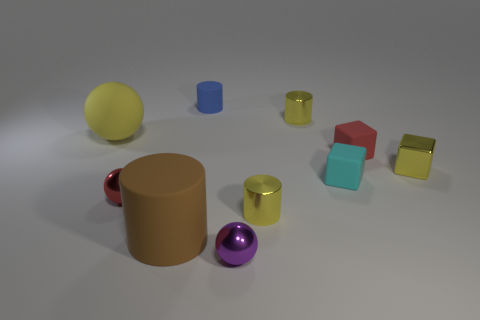Do the tiny rubber cylinder and the metallic cube have the same color?
Keep it short and to the point. No. How many small things are either purple rubber cylinders or cubes?
Ensure brevity in your answer.  3. Is there any other thing that has the same color as the big cylinder?
Offer a terse response. No. What shape is the small blue thing that is made of the same material as the cyan block?
Give a very brief answer. Cylinder. There is a metal ball to the right of the small blue matte cylinder; how big is it?
Offer a terse response. Small. What is the shape of the small cyan rubber object?
Offer a very short reply. Cube. There is a metallic ball on the left side of the purple metal sphere; is it the same size as the red object that is to the right of the purple sphere?
Keep it short and to the point. Yes. There is a red object that is behind the small shiny sphere that is left of the matte cylinder that is behind the large brown rubber thing; how big is it?
Offer a very short reply. Small. The small metallic object that is in front of the tiny yellow thing that is in front of the metallic sphere that is on the left side of the purple shiny thing is what shape?
Give a very brief answer. Sphere. There is a tiny yellow thing behind the big sphere; what shape is it?
Your response must be concise. Cylinder. 